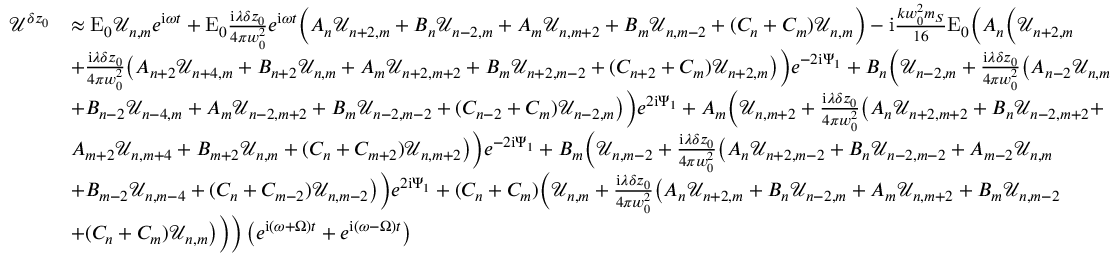Convert formula to latex. <formula><loc_0><loc_0><loc_500><loc_500>\begin{array} { r l } { \mathcal { U } ^ { \delta z _ { 0 } } } & { \approx E _ { 0 } \mathcal { U } _ { n , m } e ^ { i \omega t } + E _ { 0 } \frac { i \lambda \delta z _ { 0 } } { 4 \pi w _ { 0 } ^ { 2 } } e ^ { i \omega t } \left ( A _ { n } \mathcal { U } _ { n + 2 , m } + B _ { n } \mathcal { U } _ { n - 2 , m } + A _ { m } \mathcal { U } _ { n , m + 2 } + B _ { m } \mathcal { U } _ { n , m - 2 } + ( C _ { n } + C _ { m } ) \mathcal { U } _ { n , m } \right ) - i \frac { k w _ { 0 } ^ { 2 } m _ { S } } { 1 6 } E _ { 0 } \left ( A _ { n } \left ( \mathcal { U } _ { n + 2 , m } } \\ & { + \frac { i \lambda \delta z _ { 0 } } { 4 \pi w _ { 0 } ^ { 2 } } \left ( A _ { n + 2 } \mathcal { U } _ { n + 4 , m } + B _ { n + 2 } \mathcal { U } _ { n , m } + A _ { m } \mathcal { U } _ { n + 2 , m + 2 } + B _ { m } \mathcal { U } _ { n + 2 , m - 2 } + ( C _ { n + 2 } + C _ { m } ) \mathcal { U } _ { n + 2 , m } \right ) \right ) e ^ { - 2 i \Psi _ { 1 } } + B _ { n } \left ( \mathcal { U } _ { n - 2 , m } + \frac { i \lambda \delta z _ { 0 } } { 4 \pi w _ { 0 } ^ { 2 } } \left ( A _ { n - 2 } \mathcal { U } _ { n , m } } \\ & { + B _ { n - 2 } \mathcal { U } _ { n - 4 , m } + A _ { m } \mathcal { U } _ { n - 2 , m + 2 } + B _ { m } \mathcal { U } _ { n - 2 , m - 2 } + ( C _ { n - 2 } + C _ { m } ) \mathcal { U } _ { n - 2 , m } \right ) \right ) e ^ { 2 i \Psi _ { 1 } } + A _ { m } \left ( \mathcal { U } _ { n , m + 2 } + \frac { i \lambda \delta z _ { 0 } } { 4 \pi w _ { 0 } ^ { 2 } } \left ( A _ { n } \mathcal { U } _ { n + 2 , m + 2 } + B _ { n } \mathcal { U } _ { n - 2 , m + 2 } + } \\ & { A _ { m + 2 } \mathcal { U } _ { n , m + 4 } + B _ { m + 2 } \mathcal { U } _ { n , m } + ( C _ { n } + C _ { m + 2 } ) \mathcal { U } _ { n , m + 2 } \right ) \right ) e ^ { - 2 i \Psi _ { 1 } } + B _ { m } \left ( \mathcal { U } _ { n , m - 2 } + \frac { i \lambda \delta z _ { 0 } } { 4 \pi w _ { 0 } ^ { 2 } } \left ( A _ { n } \mathcal { U } _ { n + 2 , m - 2 } + B _ { n } \mathcal { U } _ { n - 2 , m - 2 } + A _ { m - 2 } \mathcal { U } _ { n , m } } \\ & { + B _ { m - 2 } \mathcal { U } _ { n , m - 4 } + ( C _ { n } + C _ { m - 2 } ) \mathcal { U } _ { n , m - 2 } \right ) \right ) e ^ { 2 i \Psi _ { 1 } } + ( C _ { n } + C _ { m } ) \left ( \mathcal { U } _ { n , m } + \frac { i \lambda \delta z _ { 0 } } { 4 \pi w _ { 0 } ^ { 2 } } \left ( A _ { n } \mathcal { U } _ { n + 2 , m } + B _ { n } \mathcal { U } _ { n - 2 , m } + A _ { m } \mathcal { U } _ { n , m + 2 } + B _ { m } \mathcal { U } _ { n , m - 2 } } \\ & { + ( C _ { n } + C _ { m } ) \mathcal { U } _ { n , m } \right ) \right ) \right ) \left ( e ^ { i ( \omega + \Omega ) t } + e ^ { i ( \omega - \Omega ) t } \right ) } \end{array}</formula> 